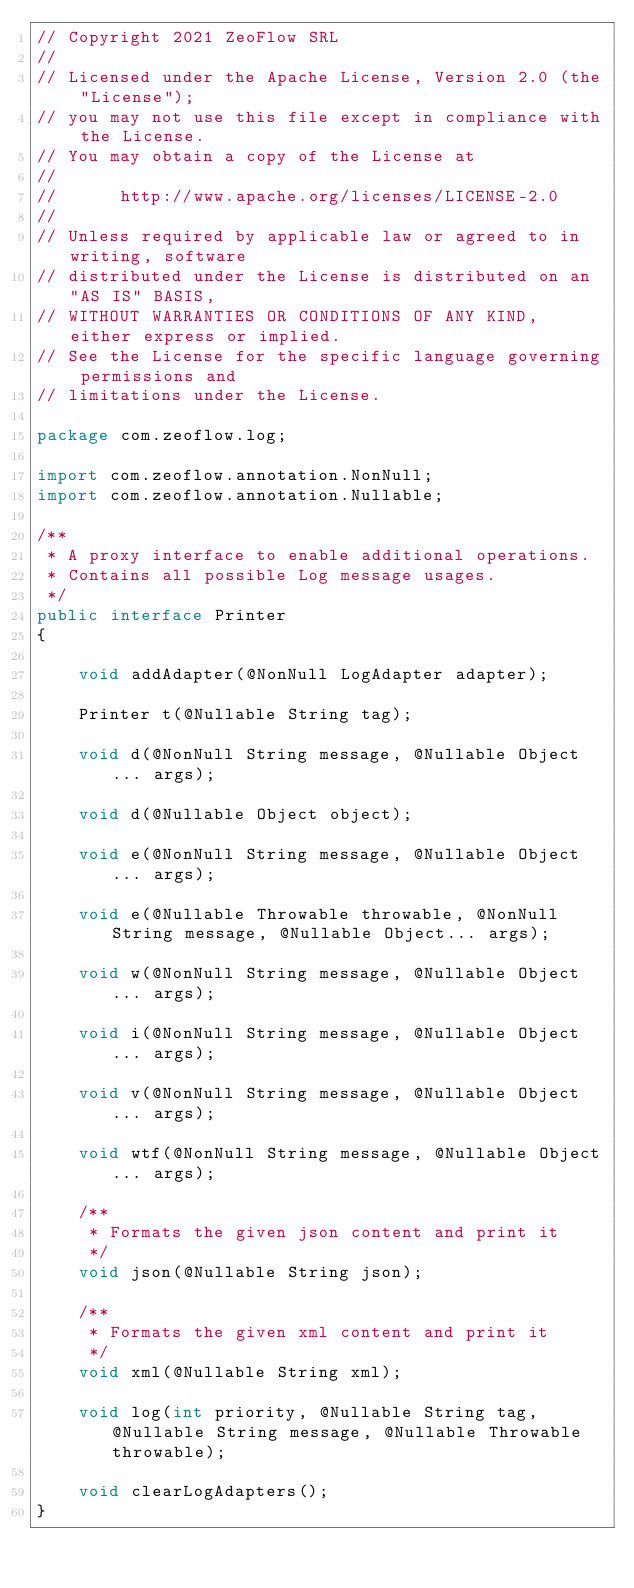Convert code to text. <code><loc_0><loc_0><loc_500><loc_500><_Java_>// Copyright 2021 ZeoFlow SRL
//
// Licensed under the Apache License, Version 2.0 (the "License");
// you may not use this file except in compliance with the License.
// You may obtain a copy of the License at
//
//      http://www.apache.org/licenses/LICENSE-2.0
//
// Unless required by applicable law or agreed to in writing, software
// distributed under the License is distributed on an "AS IS" BASIS,
// WITHOUT WARRANTIES OR CONDITIONS OF ANY KIND, either express or implied.
// See the License for the specific language governing permissions and
// limitations under the License.

package com.zeoflow.log;

import com.zeoflow.annotation.NonNull;
import com.zeoflow.annotation.Nullable;

/**
 * A proxy interface to enable additional operations.
 * Contains all possible Log message usages.
 */
public interface Printer
{

    void addAdapter(@NonNull LogAdapter adapter);

    Printer t(@Nullable String tag);

    void d(@NonNull String message, @Nullable Object... args);

    void d(@Nullable Object object);

    void e(@NonNull String message, @Nullable Object... args);

    void e(@Nullable Throwable throwable, @NonNull String message, @Nullable Object... args);

    void w(@NonNull String message, @Nullable Object... args);

    void i(@NonNull String message, @Nullable Object... args);

    void v(@NonNull String message, @Nullable Object... args);

    void wtf(@NonNull String message, @Nullable Object... args);

    /**
     * Formats the given json content and print it
     */
    void json(@Nullable String json);

    /**
     * Formats the given xml content and print it
     */
    void xml(@Nullable String xml);

    void log(int priority, @Nullable String tag, @Nullable String message, @Nullable Throwable throwable);

    void clearLogAdapters();
}
</code> 